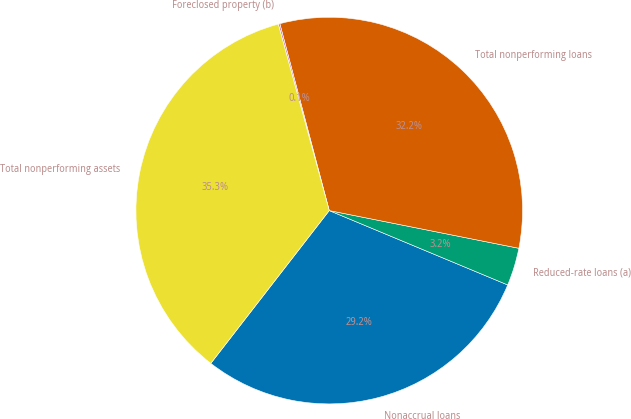Convert chart to OTSL. <chart><loc_0><loc_0><loc_500><loc_500><pie_chart><fcel>Nonaccrual loans<fcel>Reduced-rate loans (a)<fcel>Total nonperforming loans<fcel>Foreclosed property (b)<fcel>Total nonperforming assets<nl><fcel>29.21%<fcel>3.16%<fcel>32.24%<fcel>0.13%<fcel>35.26%<nl></chart> 